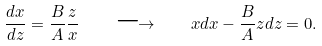<formula> <loc_0><loc_0><loc_500><loc_500>\frac { d x } { d z } = \frac { B } { A } \frac { z } { x } \quad \longrightarrow \quad x d x - \frac { B } { A } z d z = 0 .</formula> 